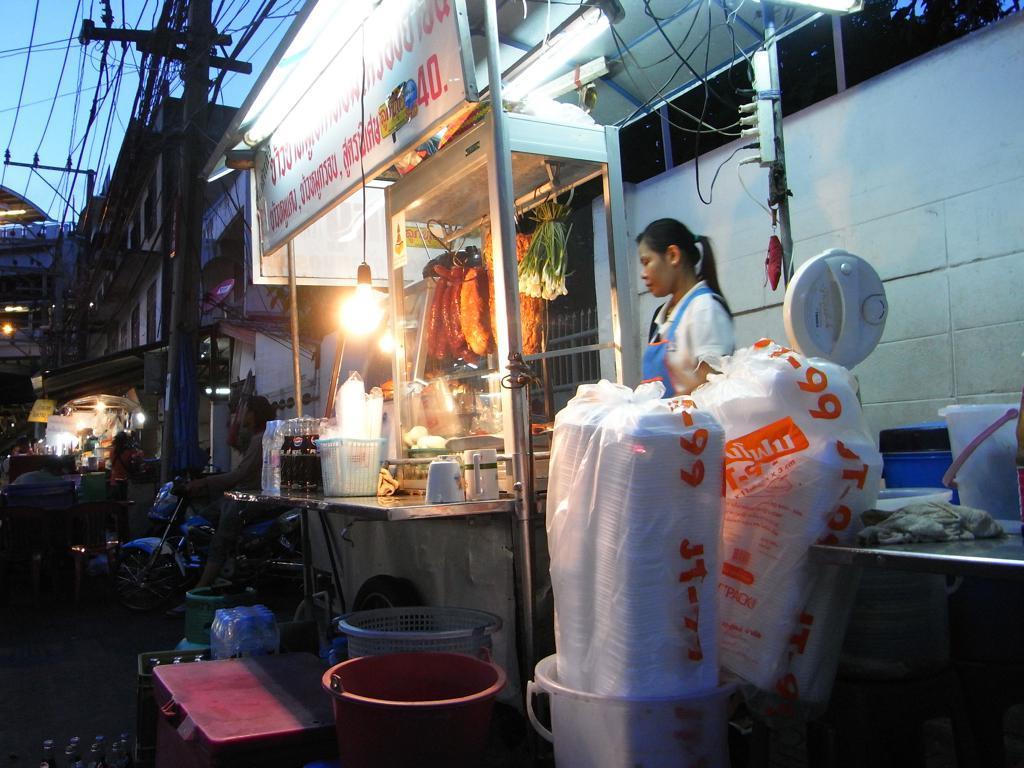In one or two sentences, can you explain what this image depicts? In the center of the image there is a person standing at the store. On the store we can see vegetables, drinks, basket, cups, covers and light. On the right side of the image we can see dustbins, bucket and covers. On the left side we can see current poles, wires, persons and vehicle. 